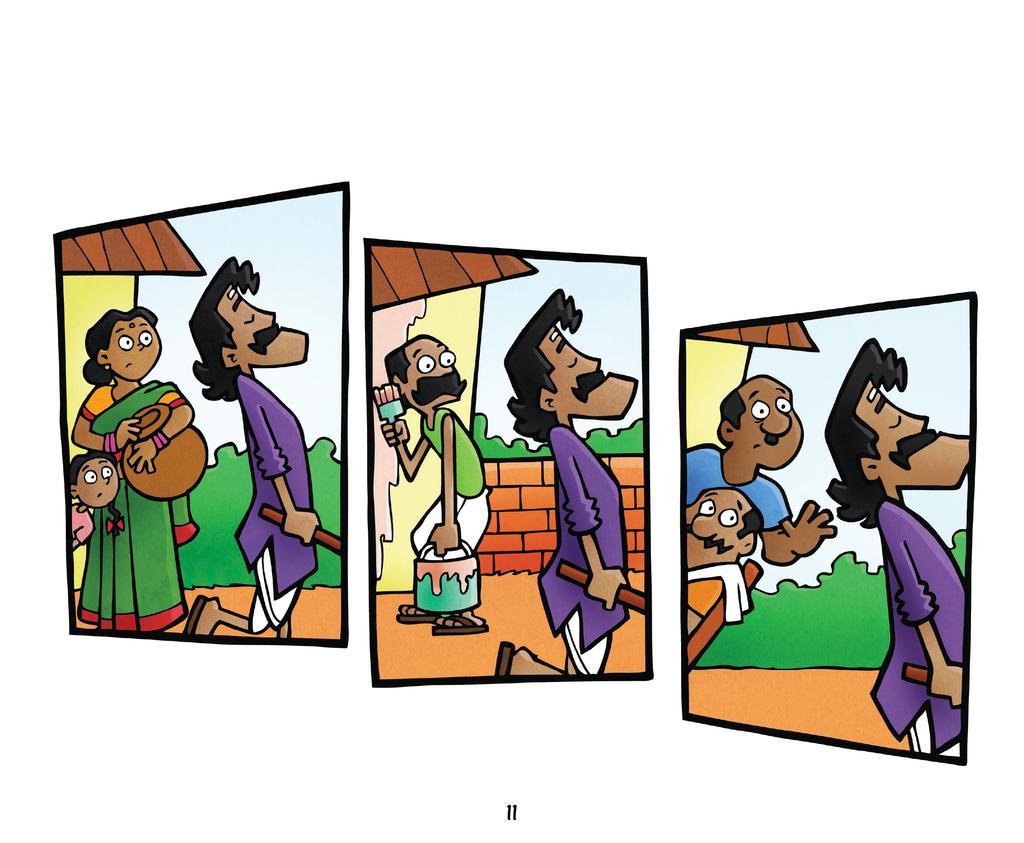Can you describe this image briefly? In this picture I can see the images in which there are cartoon characters. 